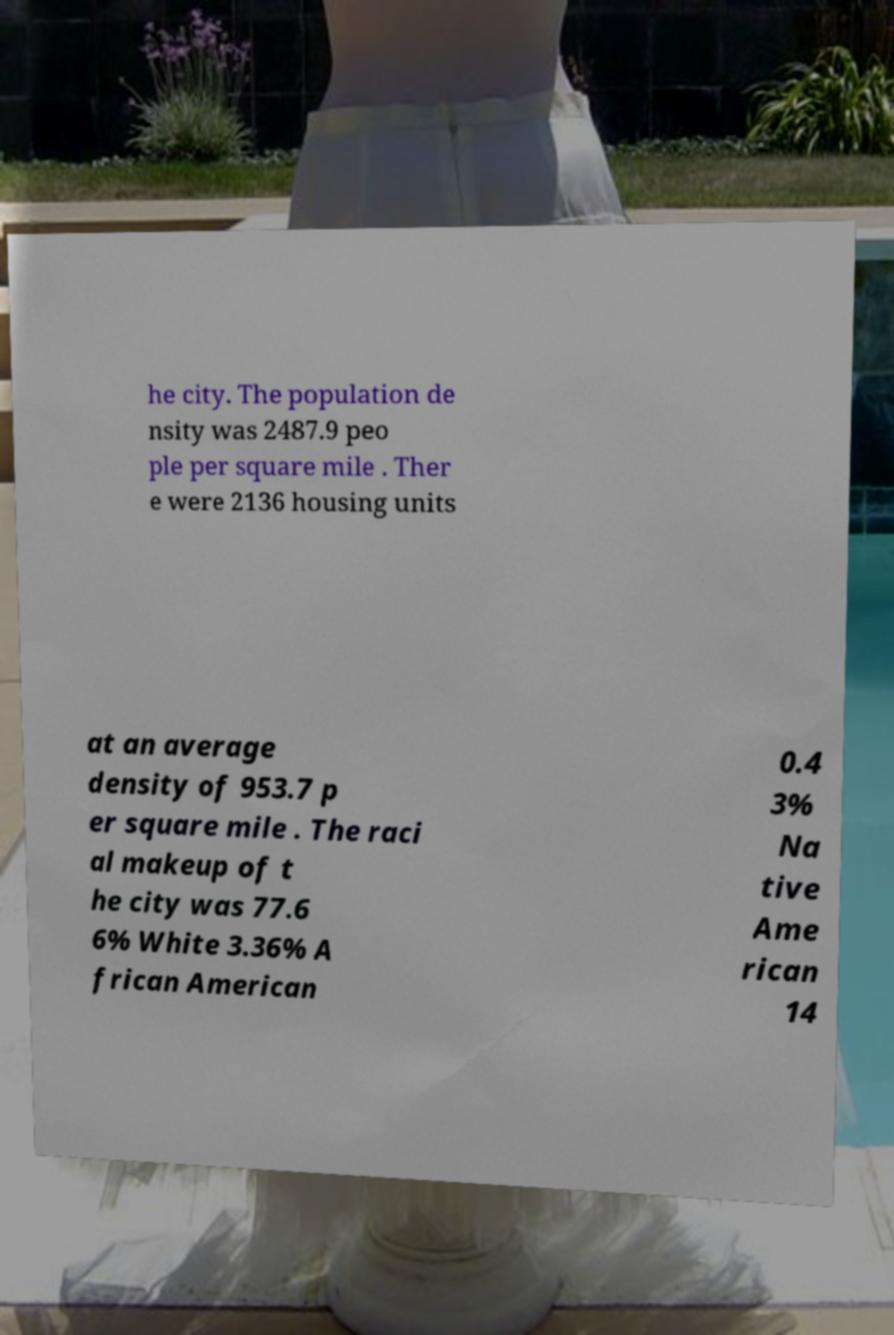For documentation purposes, I need the text within this image transcribed. Could you provide that? he city. The population de nsity was 2487.9 peo ple per square mile . Ther e were 2136 housing units at an average density of 953.7 p er square mile . The raci al makeup of t he city was 77.6 6% White 3.36% A frican American 0.4 3% Na tive Ame rican 14 